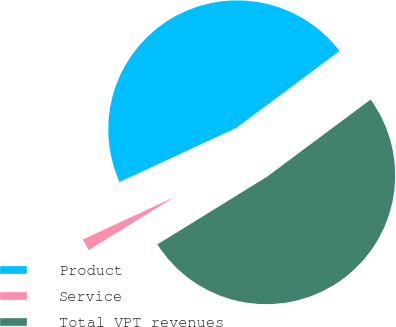Convert chart to OTSL. <chart><loc_0><loc_0><loc_500><loc_500><pie_chart><fcel>Product<fcel>Service<fcel>Total VPT revenues<nl><fcel>46.72%<fcel>1.9%<fcel>51.39%<nl></chart> 